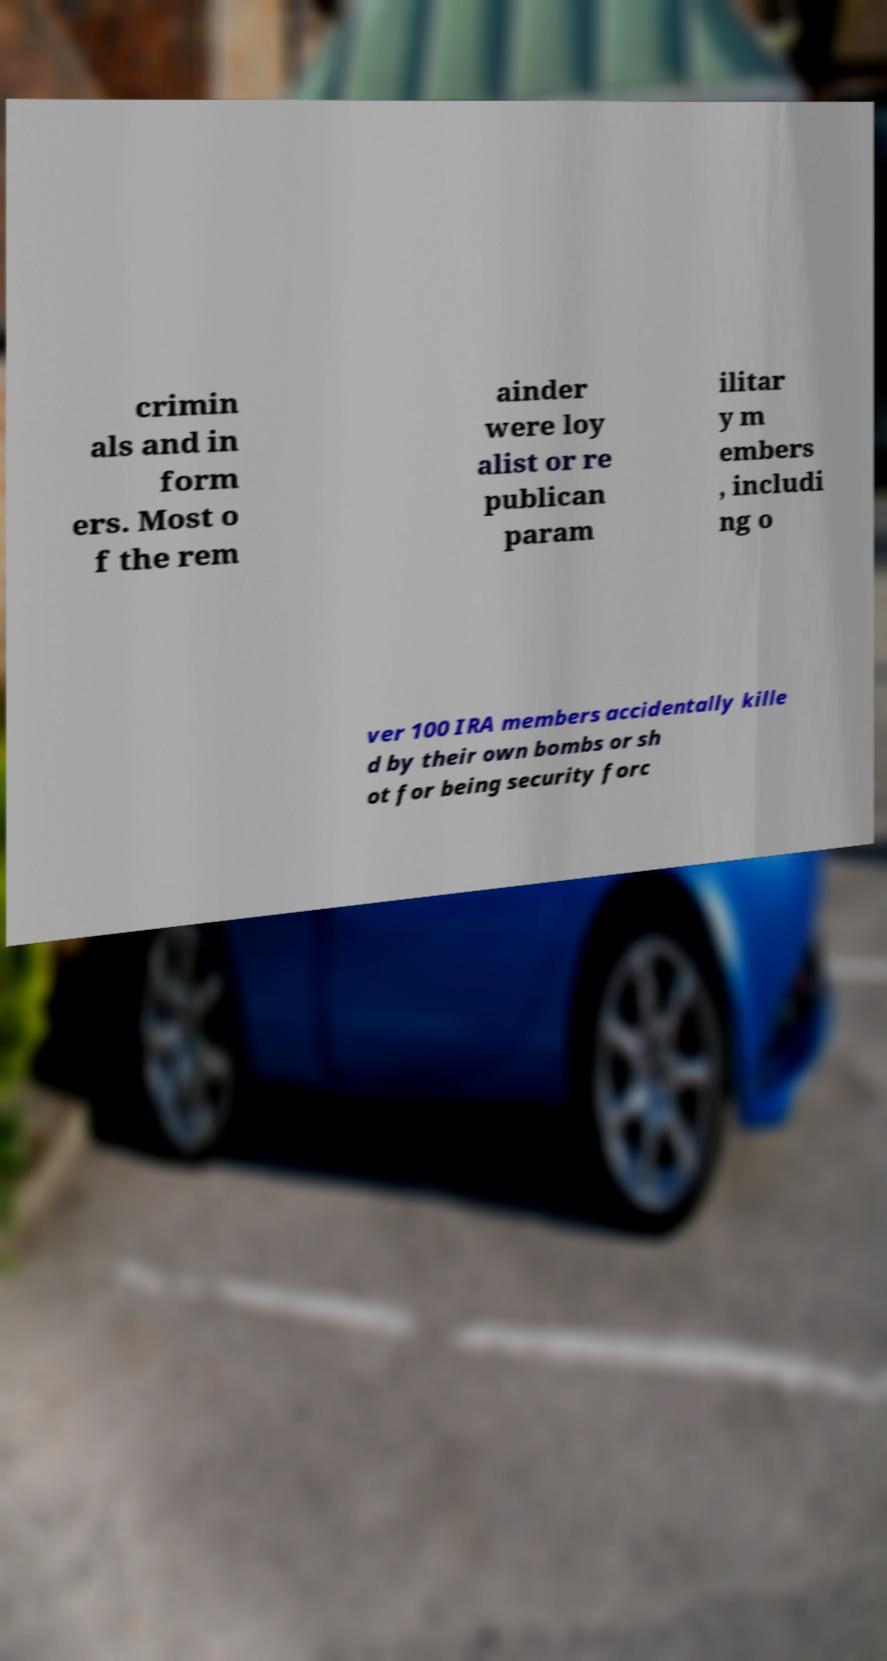Can you accurately transcribe the text from the provided image for me? crimin als and in form ers. Most o f the rem ainder were loy alist or re publican param ilitar y m embers , includi ng o ver 100 IRA members accidentally kille d by their own bombs or sh ot for being security forc 